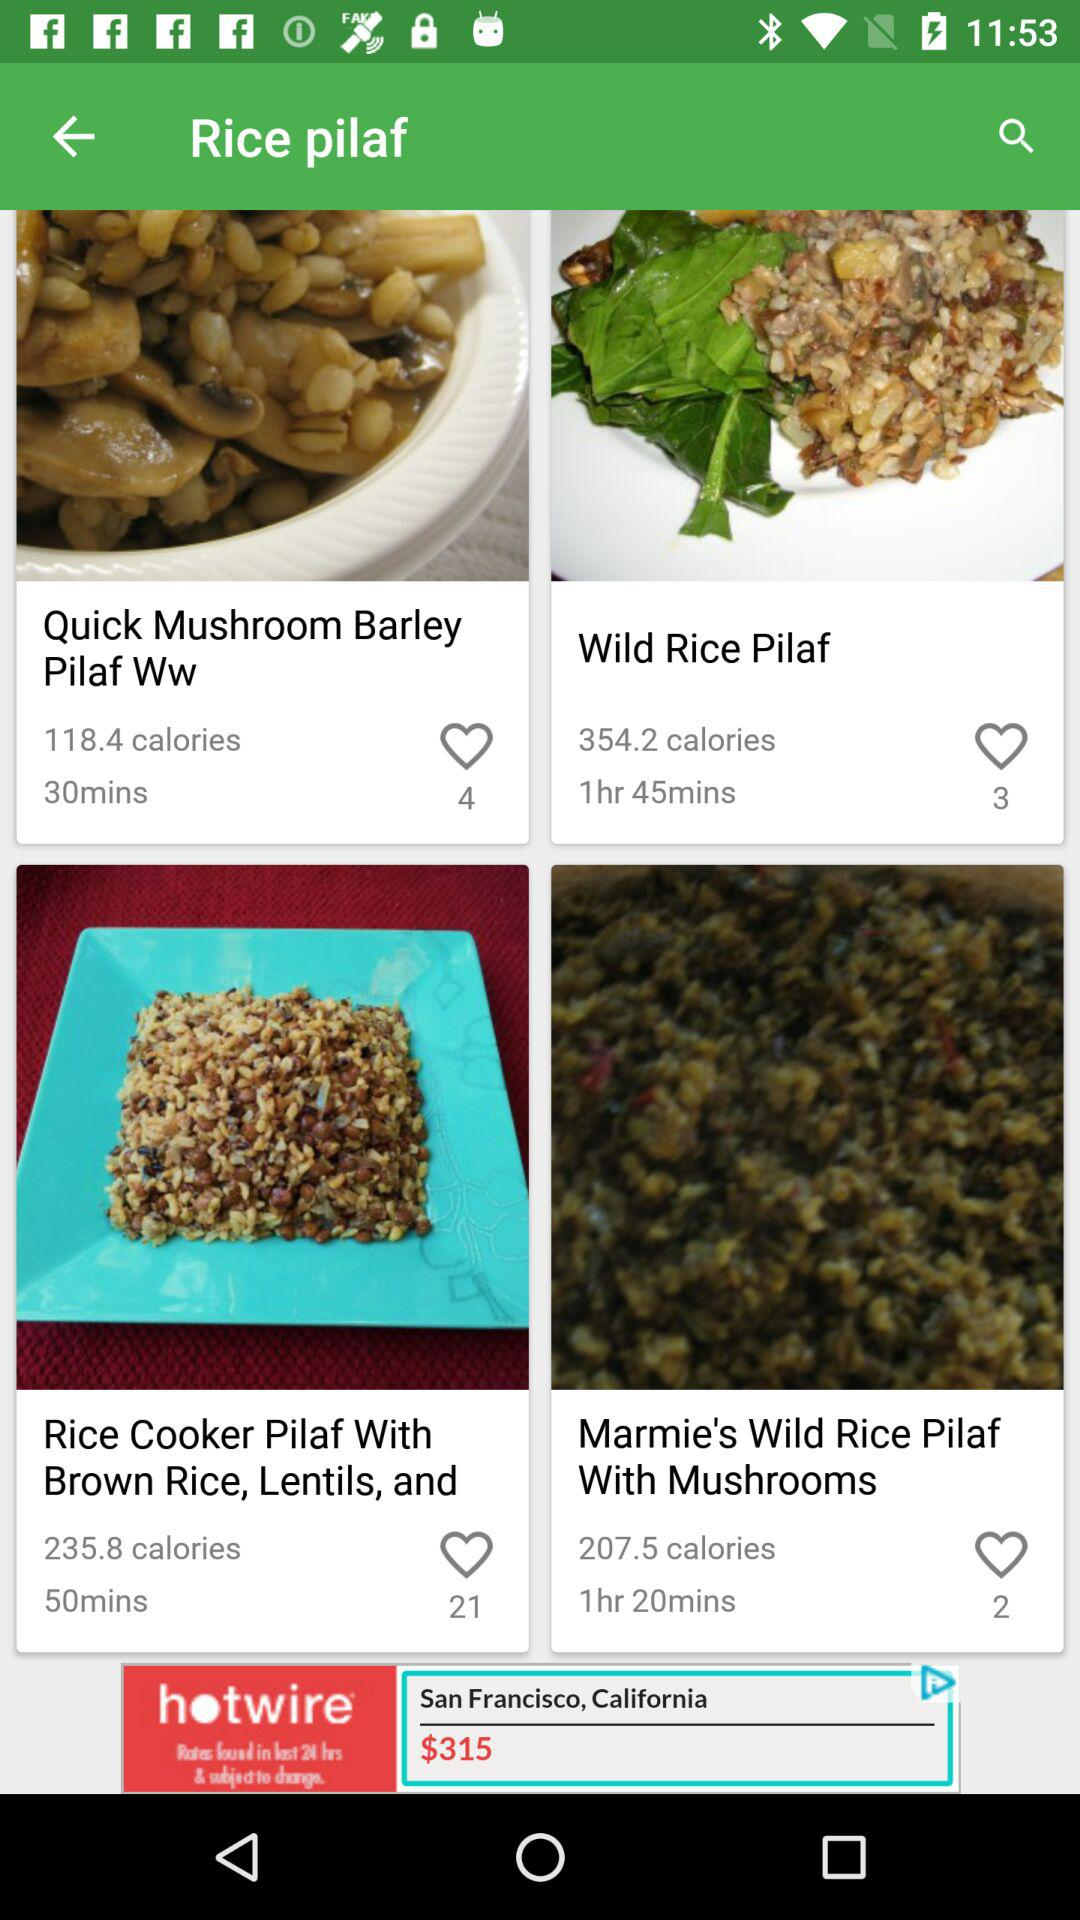What dish is prepared in 30 minutes? The dish is "Quick Mushroom Barley Pilaf Ww". 